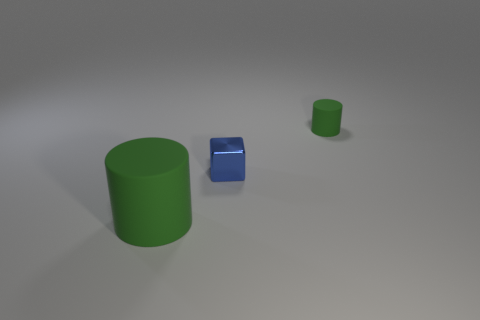How would you interpret the arrangement of these objects? The arrangement of the objects conveys a sense of deliberate placement, as though each item has been positioned for a particular purpose or comparison. The spacing between the objects could indicate an examination of their relative sizes or an artistic choice to create a balanced composition within the frame. 